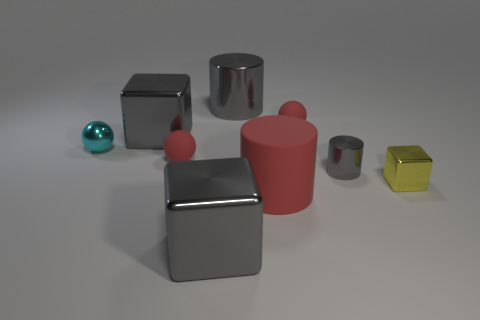Subtract all tiny red rubber balls. How many balls are left? 1 Add 1 yellow objects. How many objects exist? 10 Subtract all cylinders. How many objects are left? 6 Add 1 small cyan balls. How many small cyan balls are left? 2 Add 4 purple shiny cylinders. How many purple shiny cylinders exist? 4 Subtract 2 red balls. How many objects are left? 7 Subtract all large metallic cylinders. Subtract all small green matte cylinders. How many objects are left? 8 